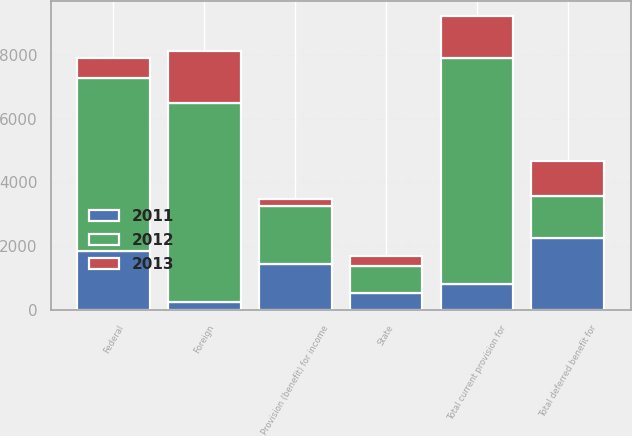Convert chart. <chart><loc_0><loc_0><loc_500><loc_500><stacked_bar_chart><ecel><fcel>State<fcel>Foreign<fcel>Total current provision for<fcel>Federal<fcel>Total deferred benefit for<fcel>Provision (benefit) for income<nl><fcel>2012<fcel>857<fcel>6222<fcel>7079<fcel>5412<fcel>1327<fcel>1823<nl><fcel>2013<fcel>300<fcel>1627<fcel>1327<fcel>608<fcel>1098<fcel>229<nl><fcel>2011<fcel>536<fcel>272<fcel>808<fcel>1861<fcel>2252<fcel>1444<nl></chart> 